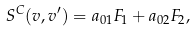Convert formula to latex. <formula><loc_0><loc_0><loc_500><loc_500>S ^ { C } ( { v } , { v } ^ { \prime } ) = a _ { 0 1 } F _ { 1 } + a _ { 0 2 } F _ { 2 } ,</formula> 